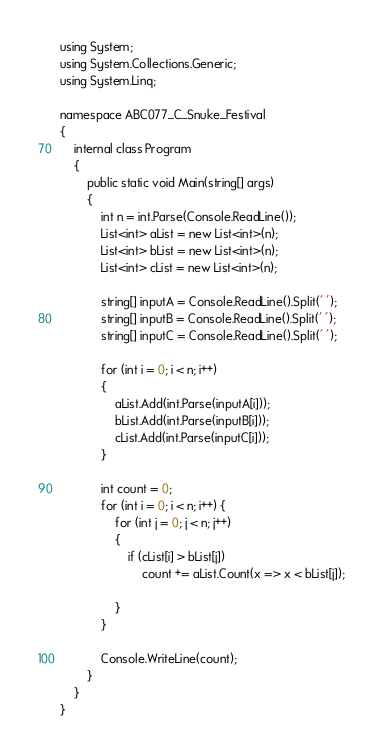<code> <loc_0><loc_0><loc_500><loc_500><_C#_>using System;
using System.Collections.Generic;
using System.Linq;

namespace ABC077_C_Snuke_Festival
{
	internal class Program
	{
		public static void Main(string[] args)
		{
			int n = int.Parse(Console.ReadLine());
			List<int> aList = new List<int>(n);
			List<int> bList = new List<int>(n);
			List<int> cList = new List<int>(n);

			string[] inputA = Console.ReadLine().Split(' '); 
			string[] inputB = Console.ReadLine().Split(' ');
			string[] inputC = Console.ReadLine().Split(' ');

			for (int i = 0; i < n; i++)
			{
				aList.Add(int.Parse(inputA[i]));
				bList.Add(int.Parse(inputB[i]));
				cList.Add(int.Parse(inputC[i]));
			}

			int count = 0;
			for (int i = 0; i < n; i++) {
				for (int j = 0; j < n; j++)
				{
					if (cList[i] > bList[j])
						count += aList.Count(x => x < bList[j]);
					
				}
			}
			
			Console.WriteLine(count);
		}
	}
}
</code> 